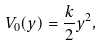<formula> <loc_0><loc_0><loc_500><loc_500>V _ { 0 } ( y ) = \frac { k } { 2 } y ^ { 2 } ,</formula> 